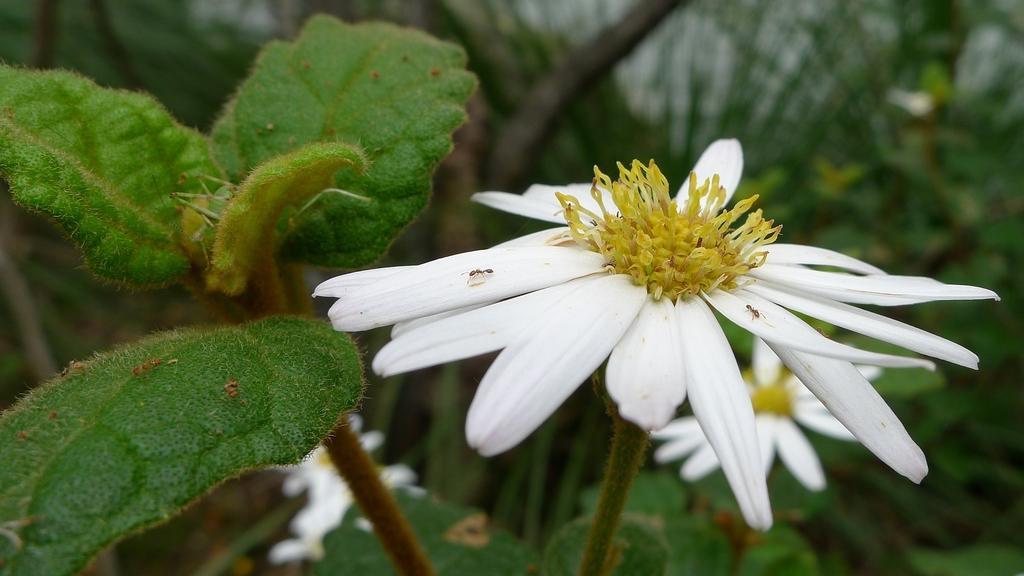Could you give a brief overview of what you see in this image? In this picture we can see white color flower on the plant. On the left we can see green leaves. 